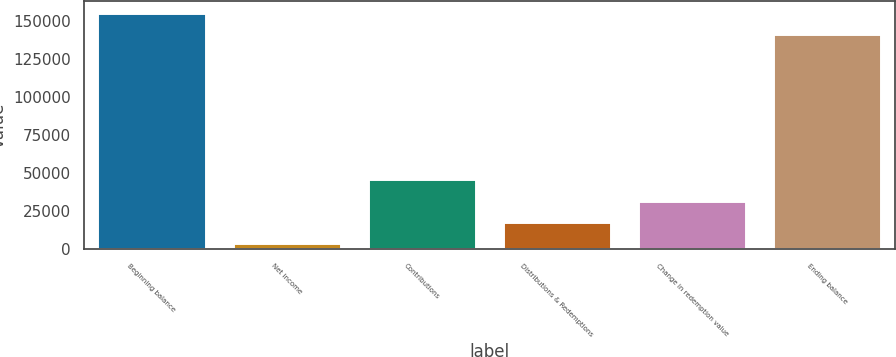Convert chart to OTSL. <chart><loc_0><loc_0><loc_500><loc_500><bar_chart><fcel>Beginning balance<fcel>Net income<fcel>Contributions<fcel>Distributions & Redemptions<fcel>Change in redemption value<fcel>Ending balance<nl><fcel>155139<fcel>3874<fcel>45820<fcel>17856<fcel>31838<fcel>141157<nl></chart> 